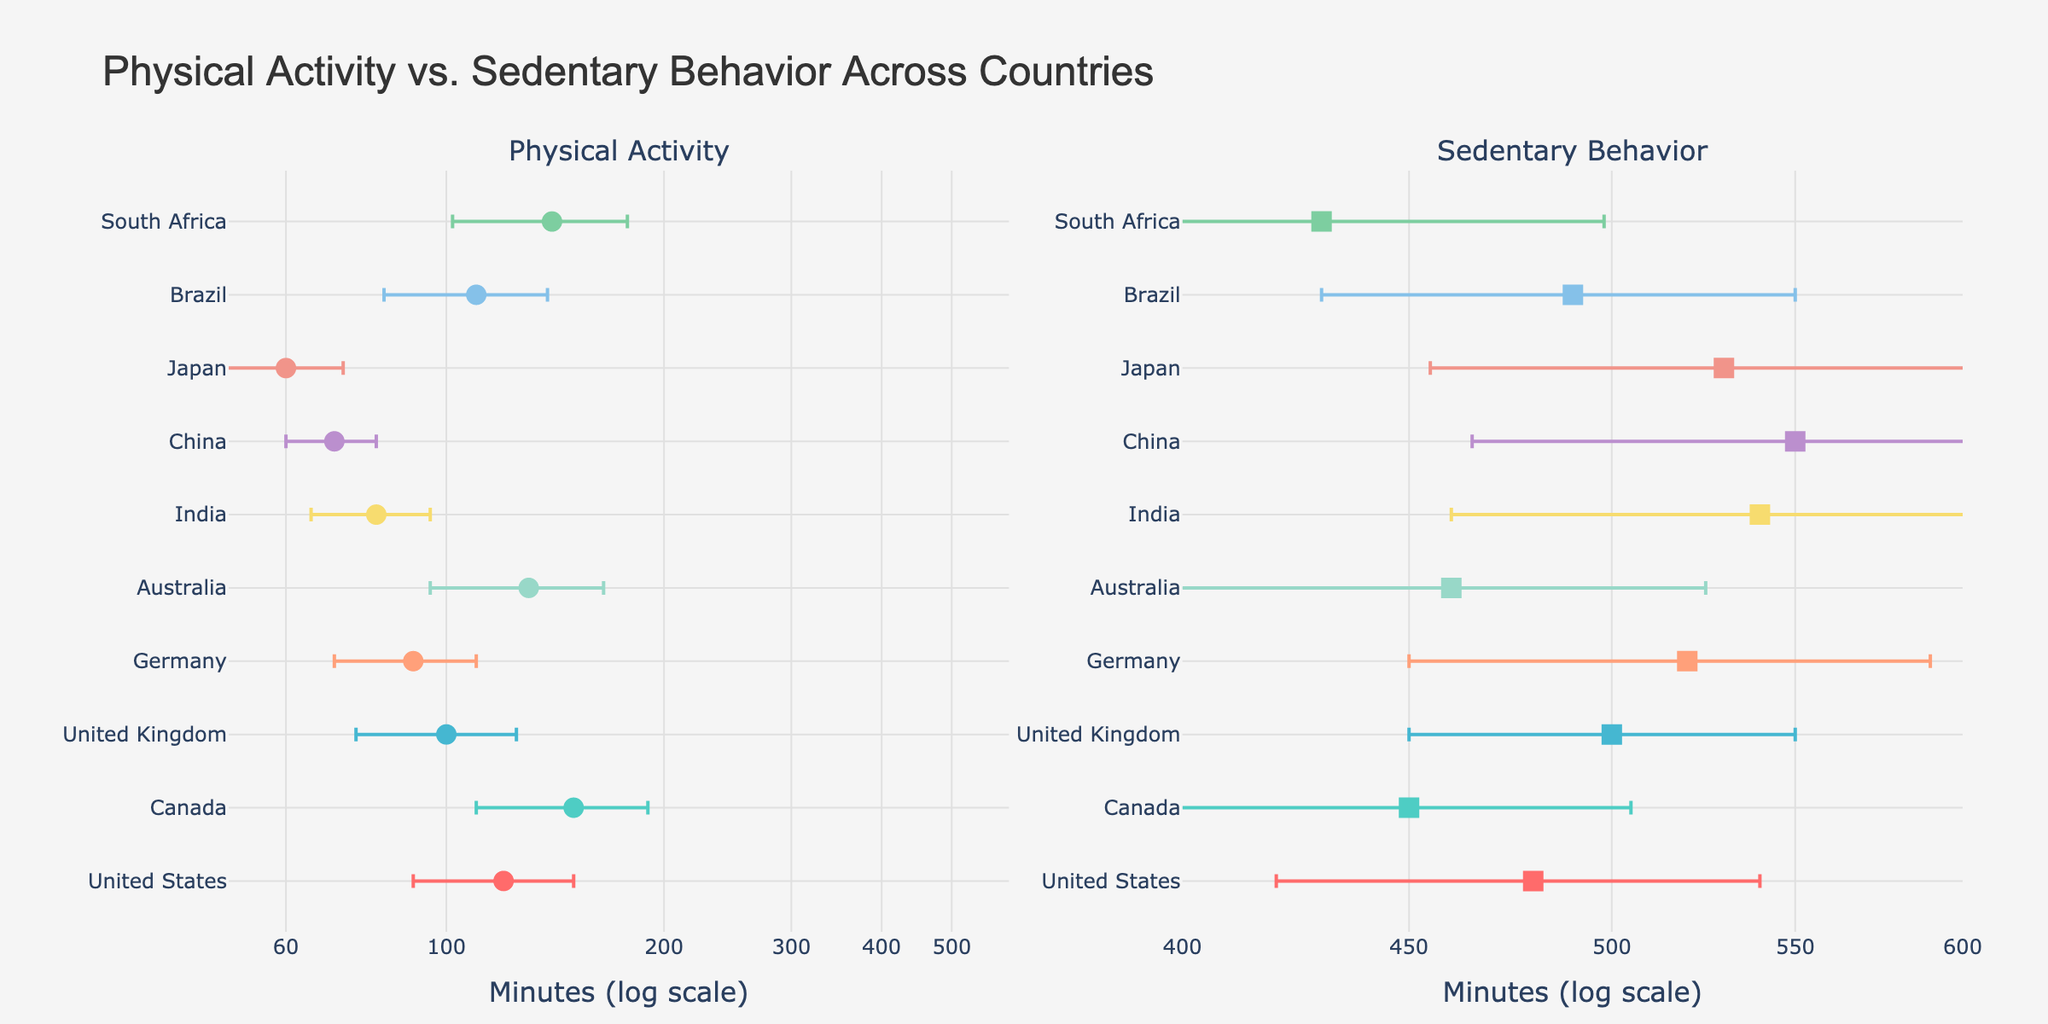What's the title of the figure? The title is prominently displayed at the top of the figure. It reads, "Physical Activity vs. Sedentary Behavior Across Countries".
Answer: Physical Activity vs. Sedentary Behavior Across Countries Which country has the highest average minutes spent on physical activity? By looking at the first subplot, we can see that Canada has the highest average minutes spent on physical activity, which is represented by the highest point on the x-axis in that plot.
Answer: Canada What is the range of sedentary behavior minutes shown in the second subplot? The x-axis of the second subplot has labels from 400 to 600 minutes displayed on a logarithmic scale. These labels indicate the range of sedentary behavior minutes.
Answer: 400-600 Which country has the smallest standard deviation in physical activity? The smallest horizontal error bar in the first subplot represents the country with the smallest standard deviation. Japan has the smallest horizontal error bar for physical activity minutes.
Answer: Japan How do the minutes of sedentary behavior in China compare to those in Brazil? In the second subplot, locate China and Brazil. China's average minutes of sedentary behavior are slightly higher than Brazil's, as China's data point is further right on the x-axis.
Answer: China > Brazil What is the difference in sedentary behavior minutes between the United Kingdom and India? In the second subplot, the United Kingdom's minutes are at 500, and India's minutes are at 540. The difference is calculated as 540 - 500 = 40 minutes.
Answer: 40 minutes Which country has the highest variability in sedentary behavior? The longest error bar (indicative of higher standard deviation) in the second subplot signifies the highest variability. India has the longest error bar for sedentary behavior.
Answer: India What pattern can you observe between physical activity and sedentary behavior across countries? Generally, countries with higher physical activity minutes tend to have lower sedentary behavior minutes and vice versa. This pattern is evident by visually comparing the positions of countries in both subplots.
Answer: Inverse relationship How does the physical activity of Australians compare to that of South Africans? In the first subplot, Australia's physical activity minutes are less than South Africa's, as seen by their positions on the x-axis.
Answer: Australia < South Africa 